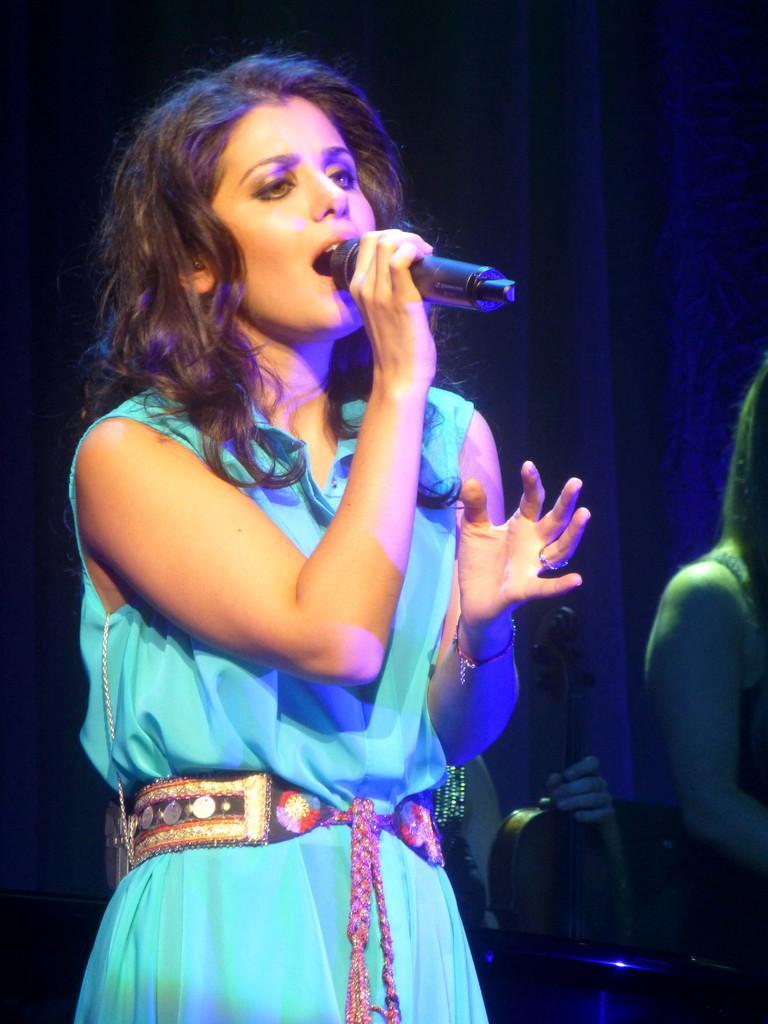In one or two sentences, can you explain what this image depicts? In this image, woman is holding microphone, she is singing. On right side, we can see few people. The person is holding a violin here. Background, we can see some cloth. 